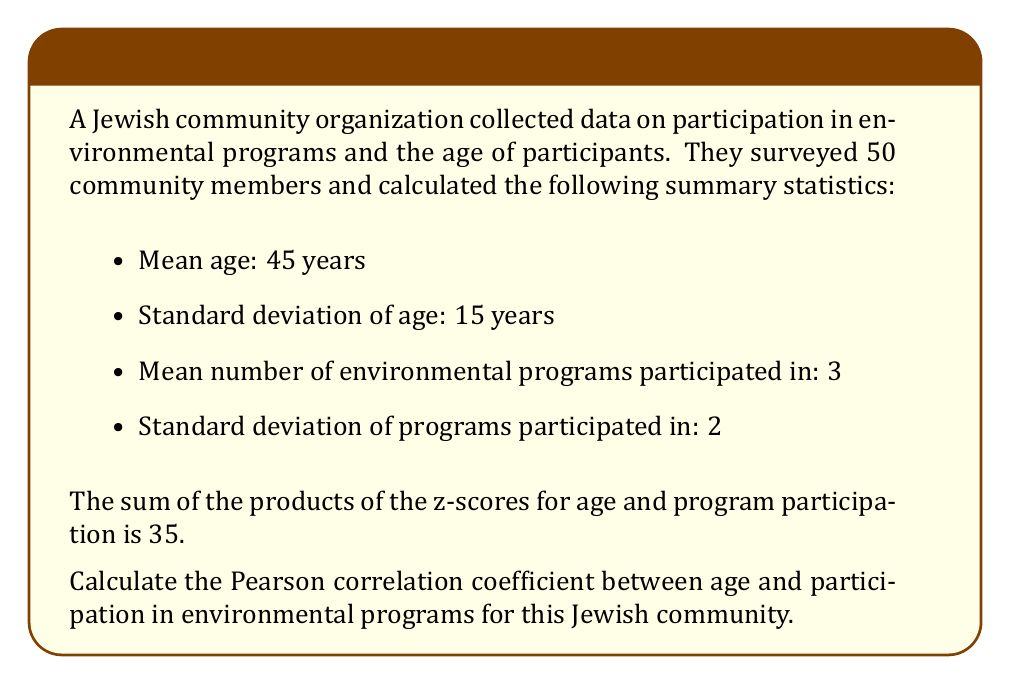Solve this math problem. To calculate the Pearson correlation coefficient, we'll follow these steps:

1) Recall the formula for the Pearson correlation coefficient:

   $$r = \frac{\sum{z_x z_y}}{n}$$

   where $z_x$ and $z_y$ are the z-scores for each variable, and $n$ is the sample size.

2) We're given that $\sum{z_x z_y} = 35$ and $n = 50$.

3) Substituting these values into the formula:

   $$r = \frac{35}{50} = 0.7$$

4) Therefore, the Pearson correlation coefficient between age and participation in environmental programs is 0.7.

5) Interpretation: This indicates a strong positive correlation between age and participation in environmental programs in this Jewish community. As age increases, participation in environmental programs tends to increase as well.
Answer: 0.7 